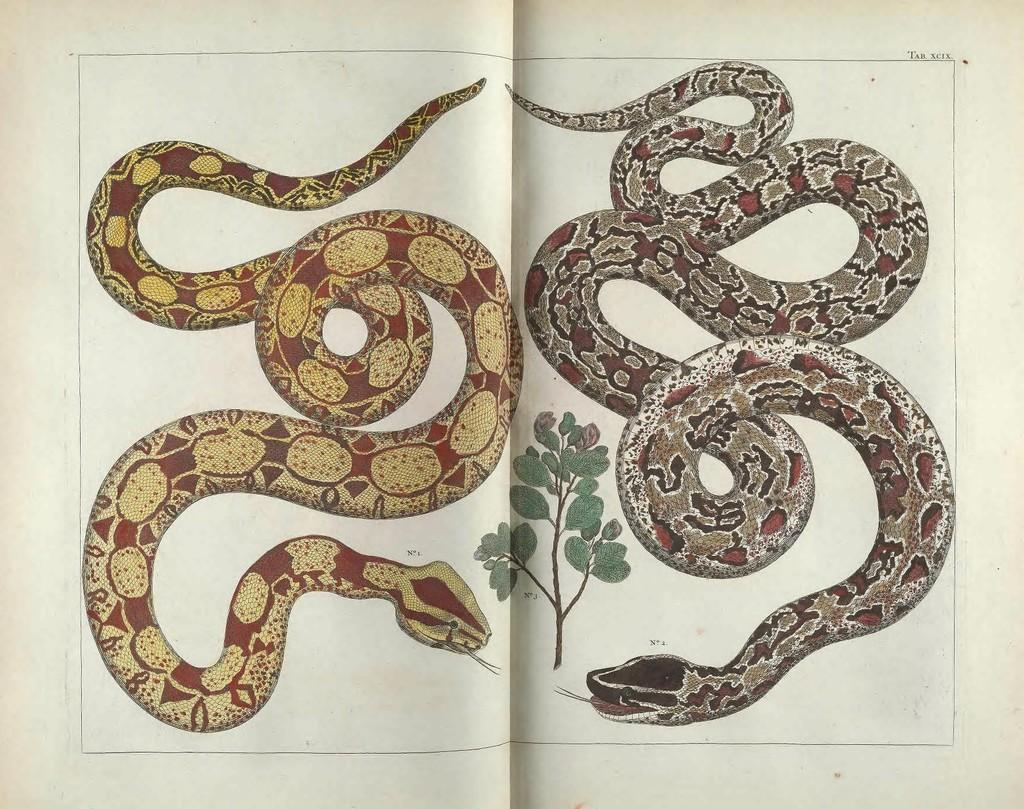What subjects are depicted in the paintings in the image? There are paintings of two snakes and a plant in the image. What is the medium of the paintings? The paintings are on a paper. What type of shade is being used by the office worker in the image? There is no office worker or shade present in the image; it features paintings on a paper. What type of approval is required for the paintings in the image? There is no indication in the image that any approval is required for the paintings. 